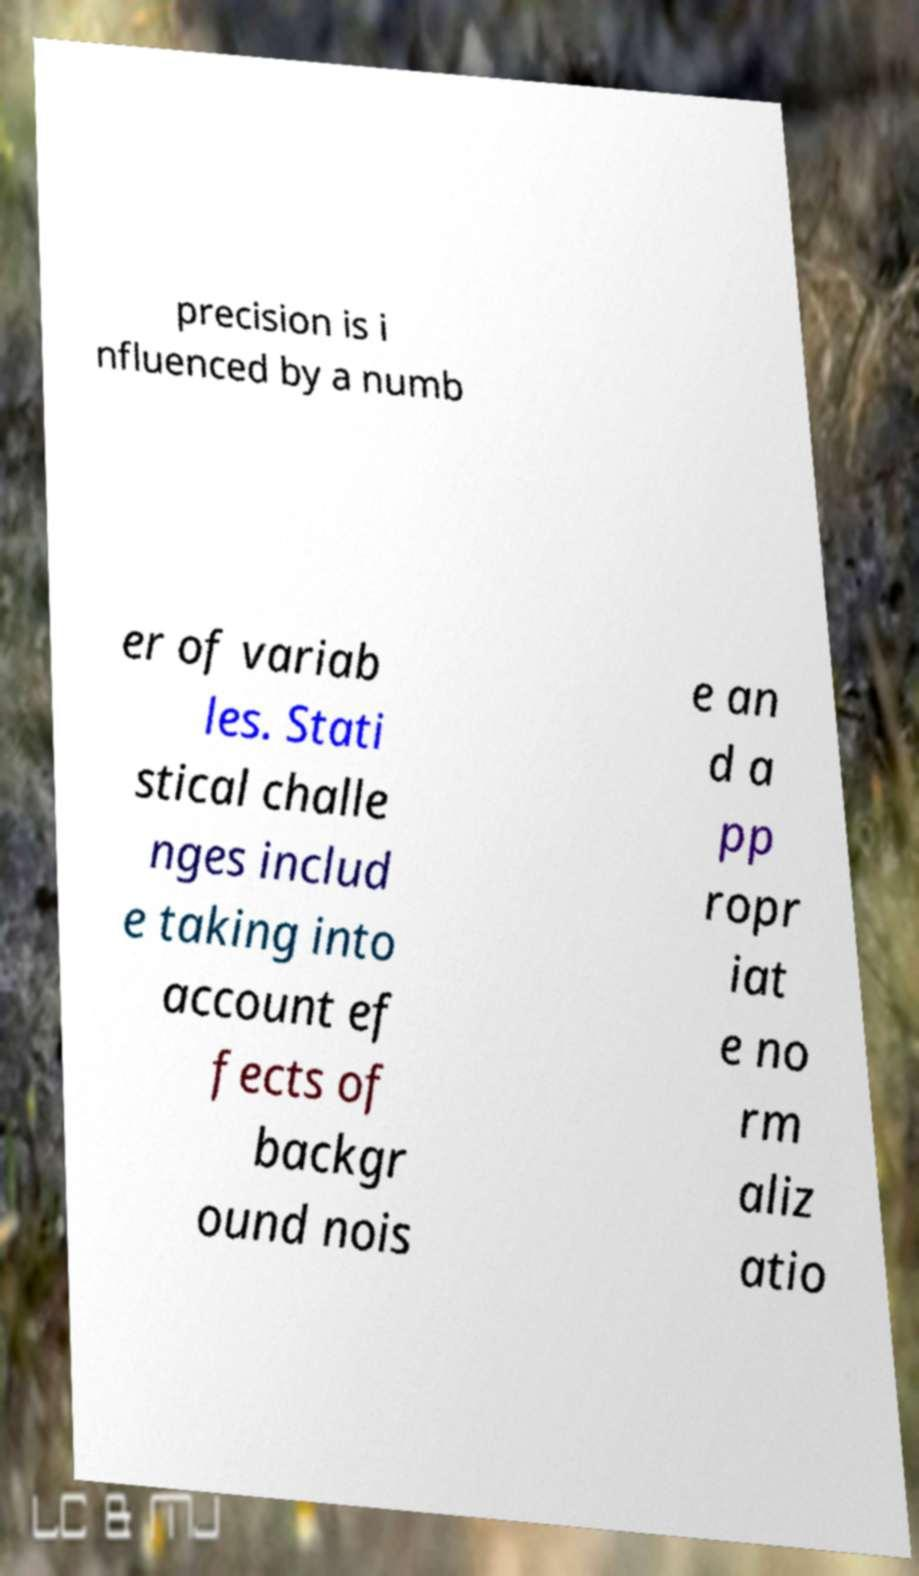Please read and relay the text visible in this image. What does it say? precision is i nfluenced by a numb er of variab les. Stati stical challe nges includ e taking into account ef fects of backgr ound nois e an d a pp ropr iat e no rm aliz atio 